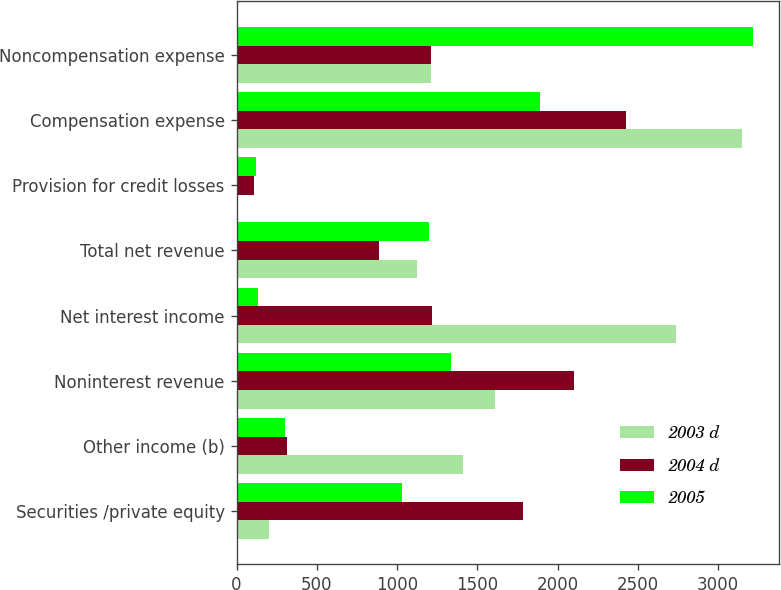Convert chart to OTSL. <chart><loc_0><loc_0><loc_500><loc_500><stacked_bar_chart><ecel><fcel>Securities /private equity<fcel>Other income (b)<fcel>Noninterest revenue<fcel>Net interest income<fcel>Total net revenue<fcel>Provision for credit losses<fcel>Compensation expense<fcel>Noncompensation expense<nl><fcel>2003 d<fcel>200<fcel>1410<fcel>1610<fcel>2736<fcel>1126<fcel>10<fcel>3151<fcel>1208.5<nl><fcel>2004 d<fcel>1786<fcel>315<fcel>2101<fcel>1216<fcel>885<fcel>110<fcel>2426<fcel>1208.5<nl><fcel>2005<fcel>1031<fcel>303<fcel>1334<fcel>133<fcel>1201<fcel>124<fcel>1893<fcel>3216<nl></chart> 